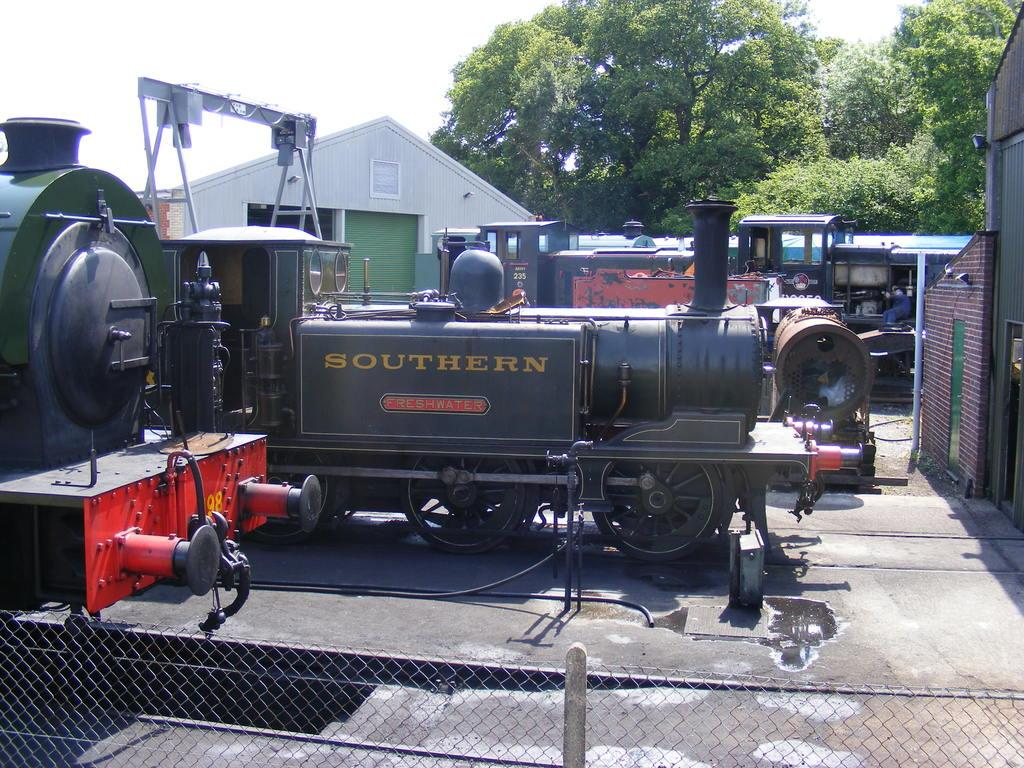What is the main subject of the image? The main subject of the image is a small train engine. Where is the train engine located in the image? The train engine is parked in the front side of the image. What is the color scheme of the house in the image? The house in the image has white and green color shades. What type of vegetation can be seen in the background of the image? There are green trees in the background of the image. What type of soup is being served in the image? There is no soup present in the image; it features a small train engine, a house, and green trees in the background. 